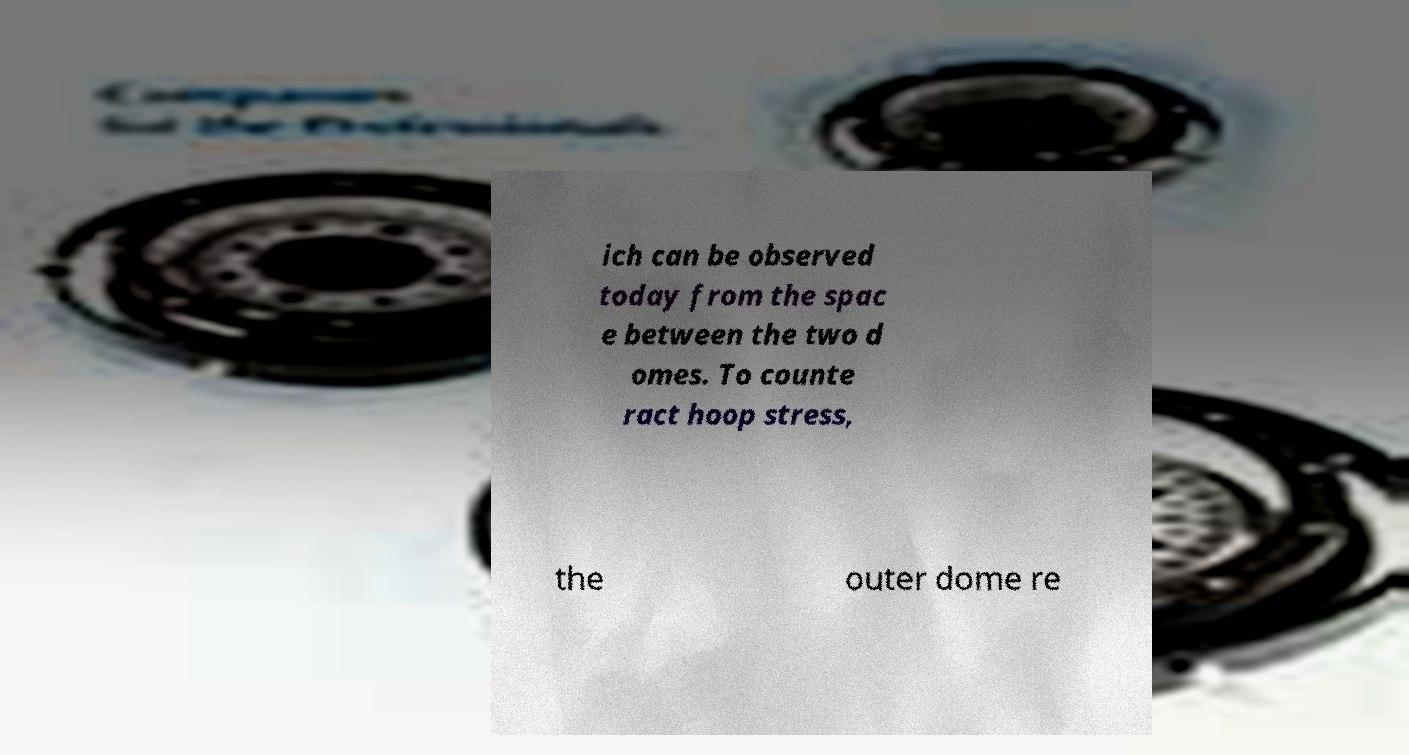I need the written content from this picture converted into text. Can you do that? ich can be observed today from the spac e between the two d omes. To counte ract hoop stress, the outer dome re 